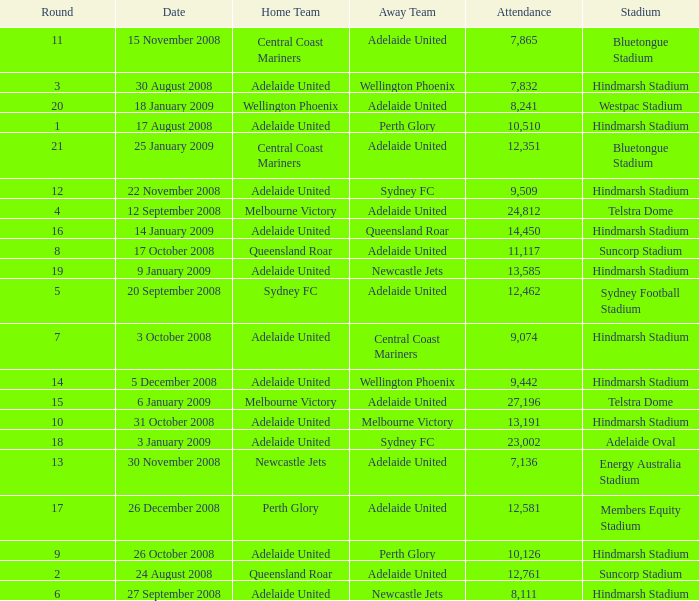What is the least round for the game played at Members Equity Stadium in from of 12,581 people? None. 